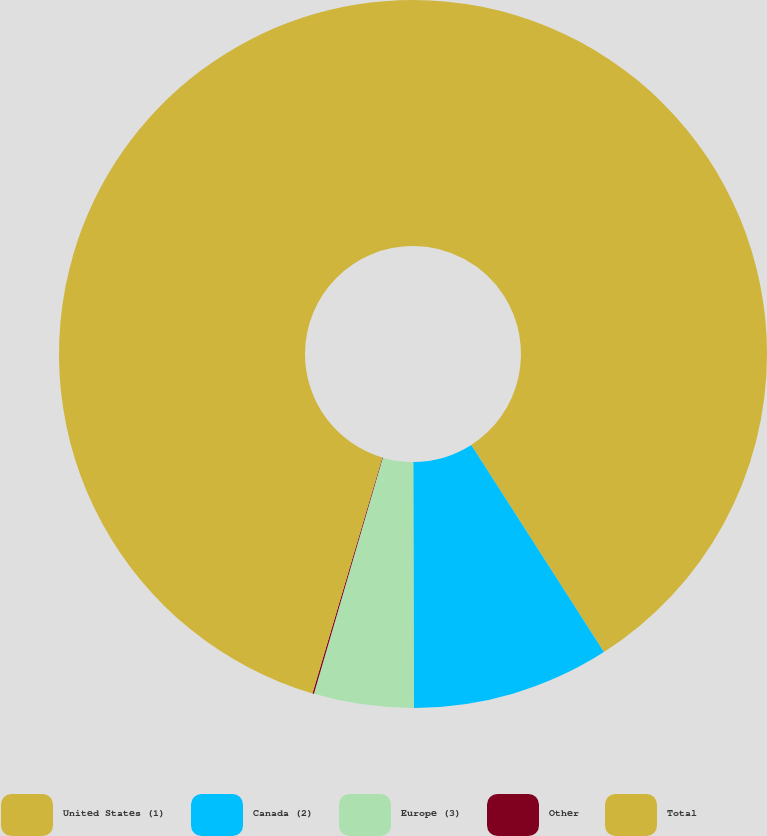<chart> <loc_0><loc_0><loc_500><loc_500><pie_chart><fcel>United States (1)<fcel>Canada (2)<fcel>Europe (3)<fcel>Other<fcel>Total<nl><fcel>40.93%<fcel>9.03%<fcel>4.55%<fcel>0.07%<fcel>45.41%<nl></chart> 